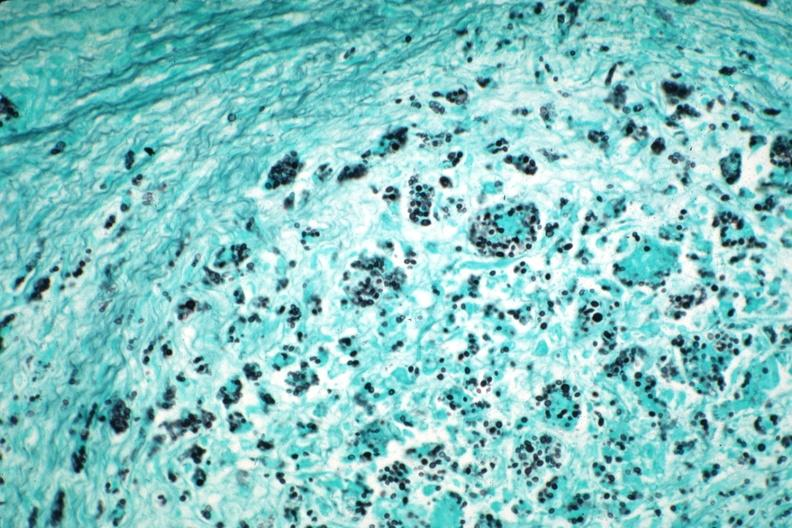what illustrates organisms granulomatous prostatitis case of aids?
Answer the question using a single word or phrase. Gms 